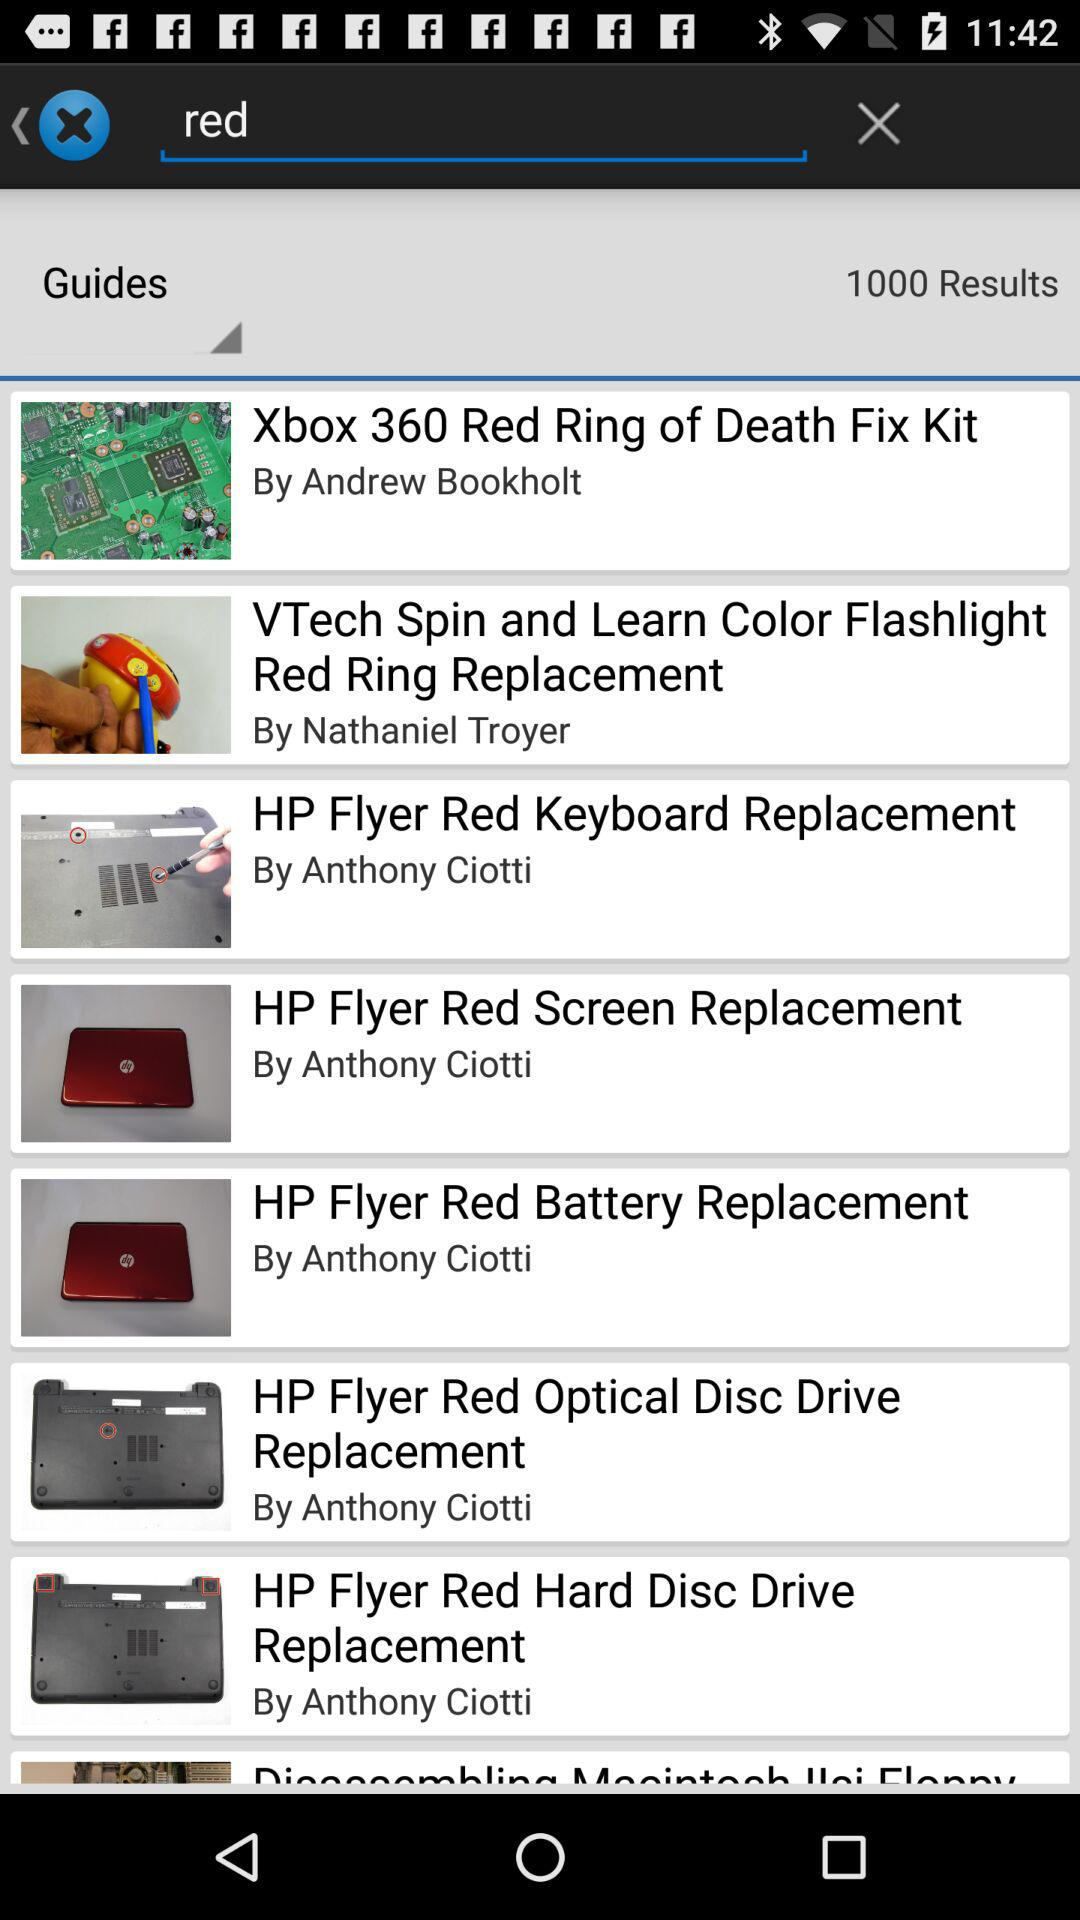Who posted the "Xbox 360 Red Ring of Death Fix Kit"? It was posted by Andrew Bookholt. 